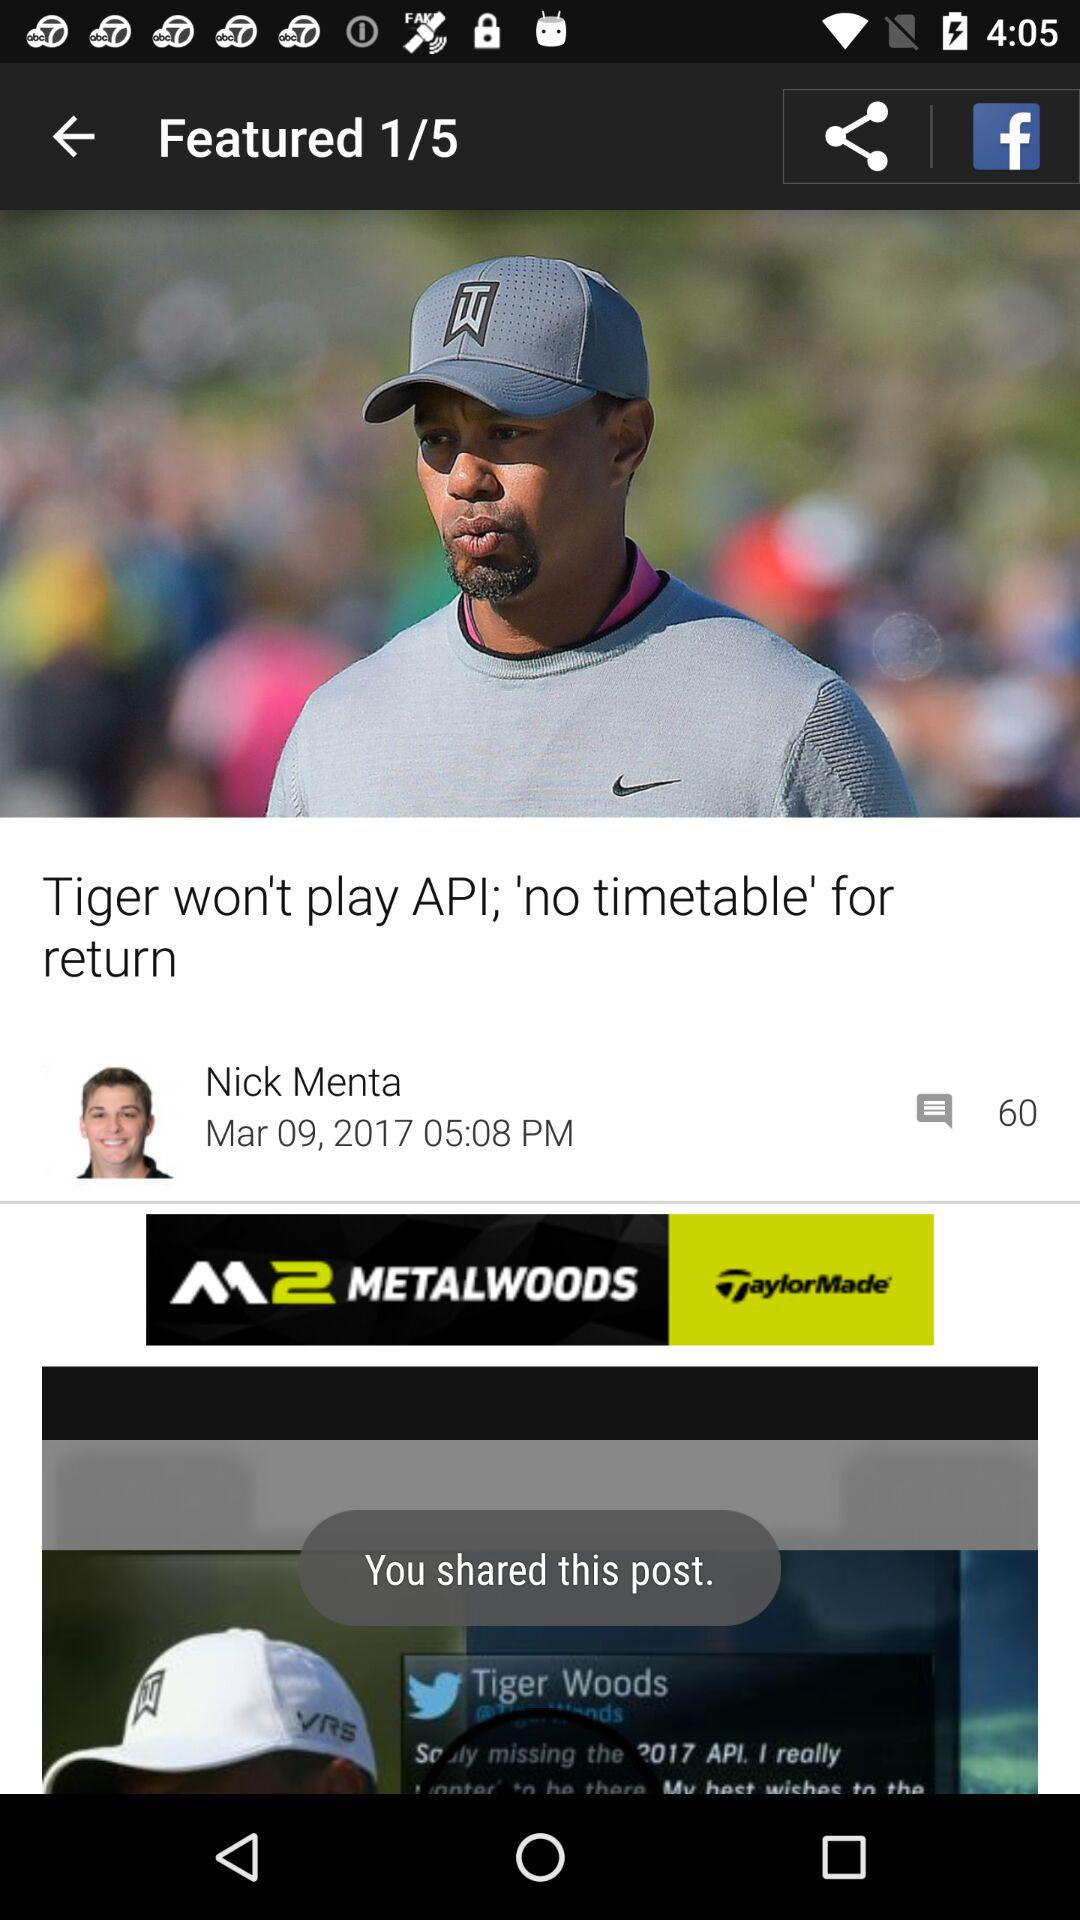What is the name of the article's author? The name of the article's author is Nick Menta. 